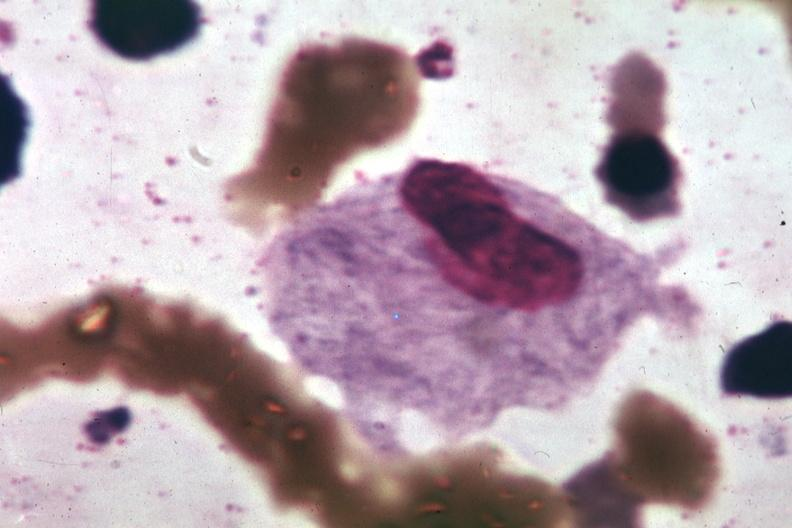s bone marrow present?
Answer the question using a single word or phrase. Yes 